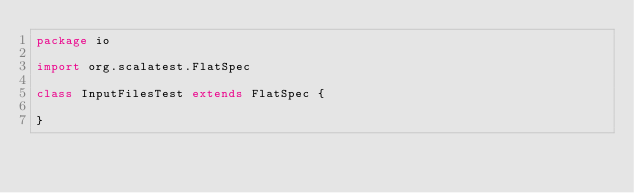Convert code to text. <code><loc_0><loc_0><loc_500><loc_500><_Scala_>package io

import org.scalatest.FlatSpec

class InputFilesTest extends FlatSpec {

}
</code> 